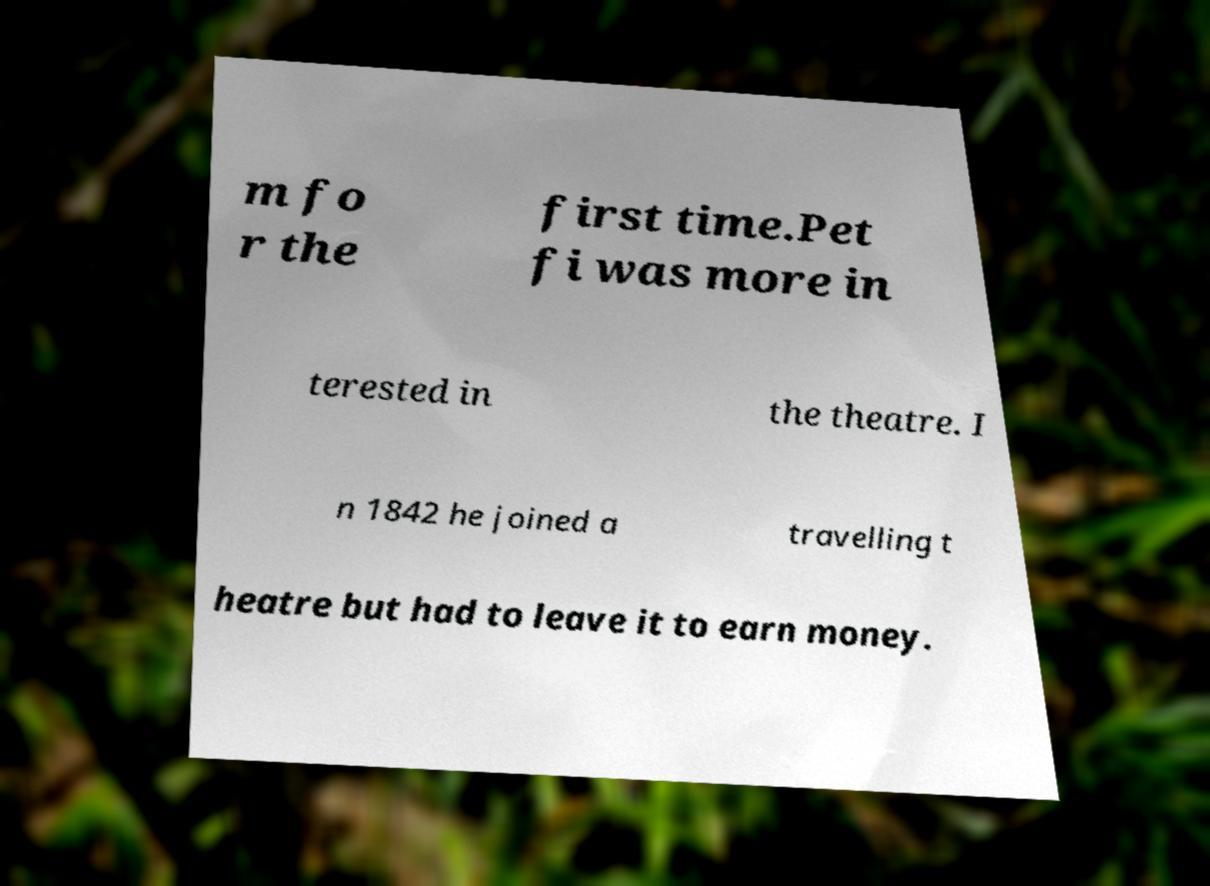Can you read and provide the text displayed in the image?This photo seems to have some interesting text. Can you extract and type it out for me? m fo r the first time.Pet fi was more in terested in the theatre. I n 1842 he joined a travelling t heatre but had to leave it to earn money. 